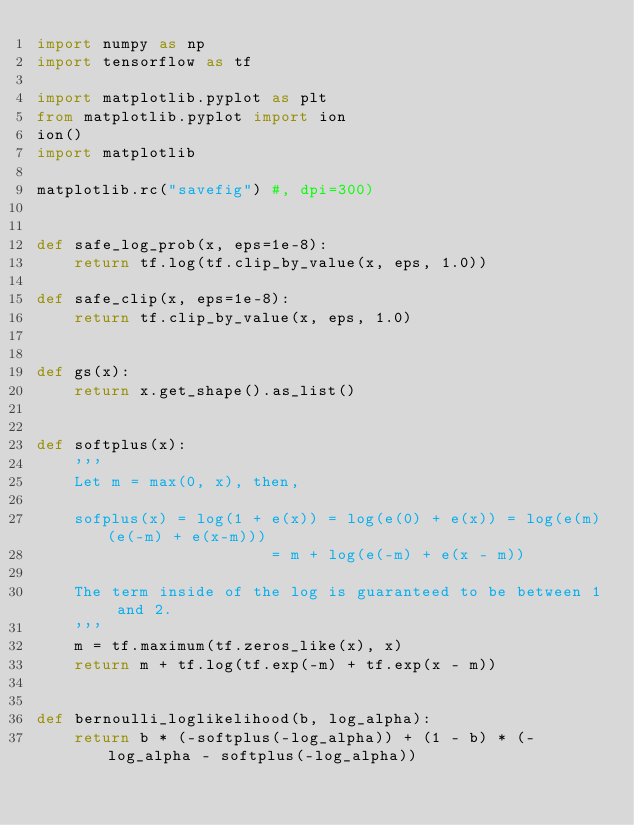Convert code to text. <code><loc_0><loc_0><loc_500><loc_500><_Python_>import numpy as np
import tensorflow as tf

import matplotlib.pyplot as plt
from matplotlib.pyplot import ion
ion()
import matplotlib

matplotlib.rc("savefig") #, dpi=300)


def safe_log_prob(x, eps=1e-8):
    return tf.log(tf.clip_by_value(x, eps, 1.0))

def safe_clip(x, eps=1e-8):
    return tf.clip_by_value(x, eps, 1.0)


def gs(x):
    return x.get_shape().as_list()


def softplus(x):
    '''
    Let m = max(0, x), then,

    sofplus(x) = log(1 + e(x)) = log(e(0) + e(x)) = log(e(m)(e(-m) + e(x-m)))
                         = m + log(e(-m) + e(x - m))

    The term inside of the log is guaranteed to be between 1 and 2.
    '''
    m = tf.maximum(tf.zeros_like(x), x)
    return m + tf.log(tf.exp(-m) + tf.exp(x - m))


def bernoulli_loglikelihood(b, log_alpha):
    return b * (-softplus(-log_alpha)) + (1 - b) * (-log_alpha - softplus(-log_alpha))

</code> 